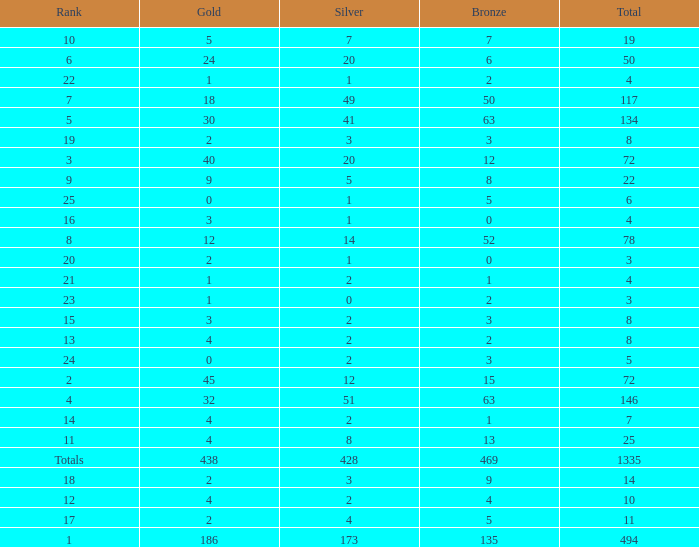What is the average number of gold medals when the total was 1335 medals, with more than 469 bronzes and more than 14 silvers? None. 